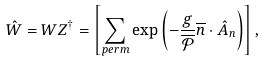Convert formula to latex. <formula><loc_0><loc_0><loc_500><loc_500>\hat { W } = W Z ^ { \dagger } = \left [ \sum _ { p e r m } \exp \left ( - \frac { g } { \overline { \mathcal { P } } } \overline { n } \cdot \hat { A } _ { n } \right ) \right ] ,</formula> 